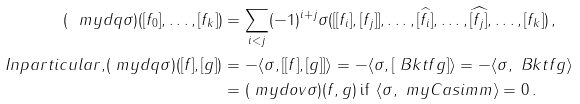<formula> <loc_0><loc_0><loc_500><loc_500>( \ m y d q \sigma ) ( [ f _ { 0 } ] , \dots , [ f _ { k } ] ) & = \sum _ { i < j } ( - 1 ) ^ { i + j } \sigma ( [ [ f _ { i } ] , [ f _ { j } ] ] , \dots , \widehat { [ f _ { i } ] } , \dots , \widehat { [ f _ { j } ] } , \dots , [ f _ { k } ] ) \, , \\ { I n p a r t i c u l a r , } ( \ m y d q \sigma ) ( [ f ] , [ g ] ) & = - \langle \sigma , [ [ f ] , [ g ] ] \rangle = - \langle \sigma , [ \ B k t { f } { g } ] \rangle = - \langle \sigma , \ B k t { f } { g } \rangle \\ & = ( \ m y d o v \sigma ) ( f , g ) \, \text {if } \, \langle \sigma , \ m y C a s i m m \rangle = 0 \, .</formula> 